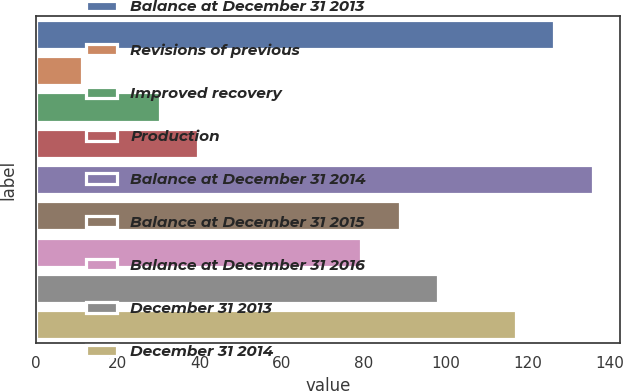Convert chart to OTSL. <chart><loc_0><loc_0><loc_500><loc_500><bar_chart><fcel>Balance at December 31 2013<fcel>Revisions of previous<fcel>Improved recovery<fcel>Production<fcel>Balance at December 31 2014<fcel>Balance at December 31 2015<fcel>Balance at December 31 2016<fcel>December 31 2013<fcel>December 31 2014<nl><fcel>126.4<fcel>11.4<fcel>30.2<fcel>39.6<fcel>135.8<fcel>88.8<fcel>79.4<fcel>98.2<fcel>117<nl></chart> 